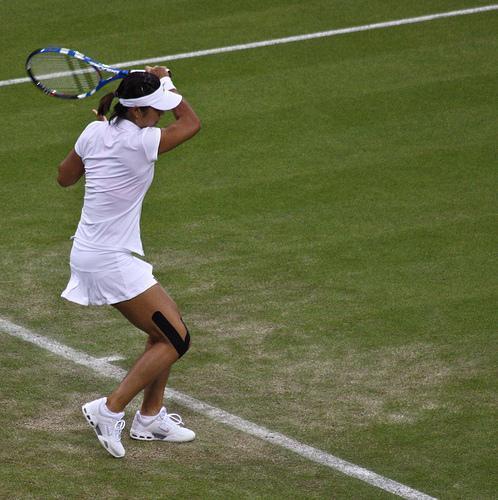How many people on the tennis court?
Give a very brief answer. 1. 